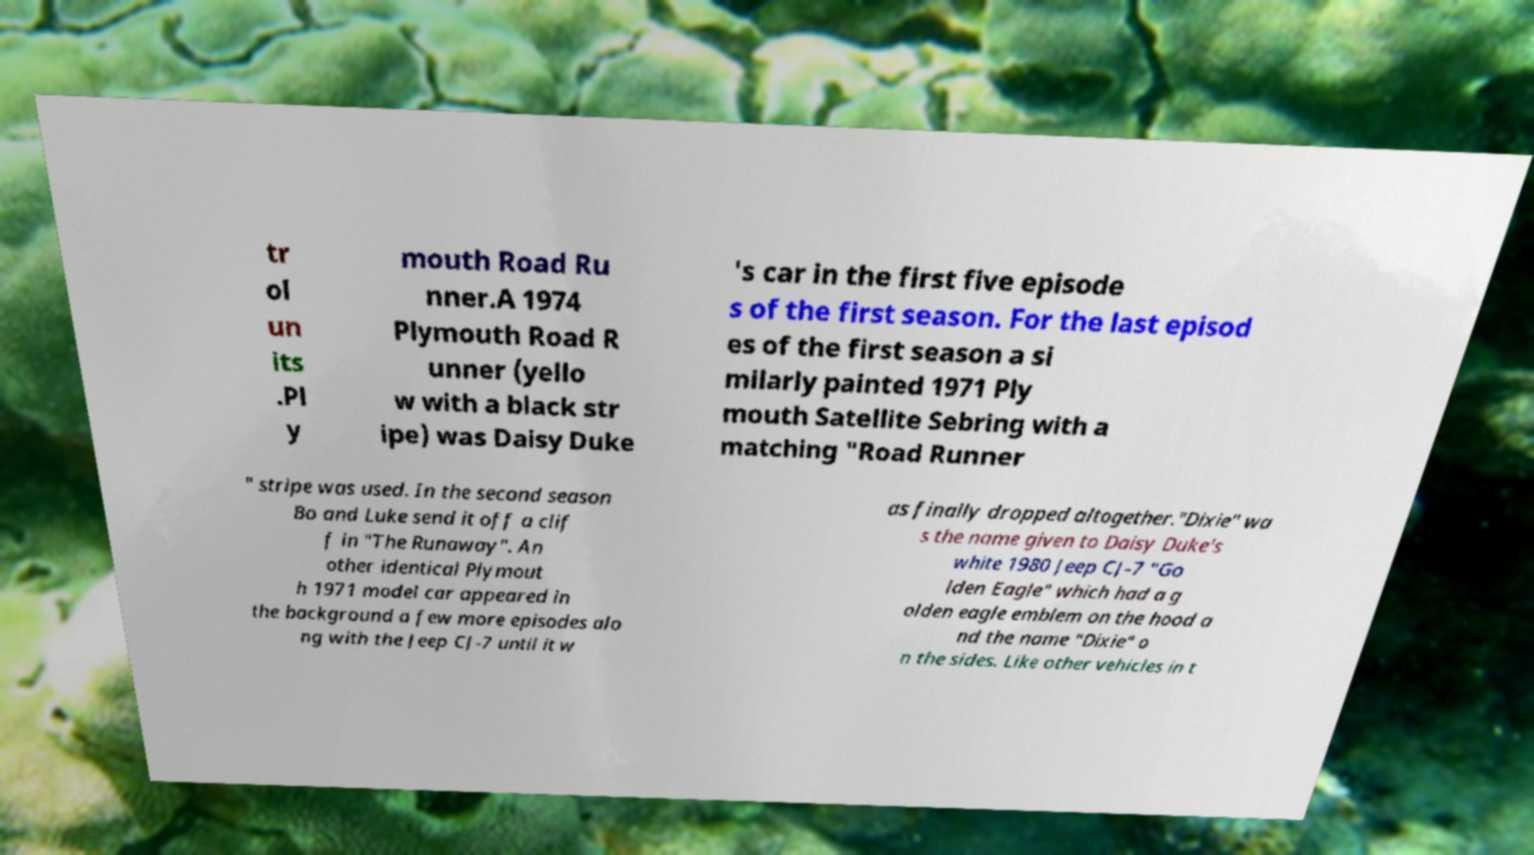I need the written content from this picture converted into text. Can you do that? tr ol un its .Pl y mouth Road Ru nner.A 1974 Plymouth Road R unner (yello w with a black str ipe) was Daisy Duke 's car in the first five episode s of the first season. For the last episod es of the first season a si milarly painted 1971 Ply mouth Satellite Sebring with a matching "Road Runner " stripe was used. In the second season Bo and Luke send it off a clif f in "The Runaway". An other identical Plymout h 1971 model car appeared in the background a few more episodes alo ng with the Jeep CJ-7 until it w as finally dropped altogether."Dixie" wa s the name given to Daisy Duke's white 1980 Jeep CJ-7 "Go lden Eagle" which had a g olden eagle emblem on the hood a nd the name "Dixie" o n the sides. Like other vehicles in t 